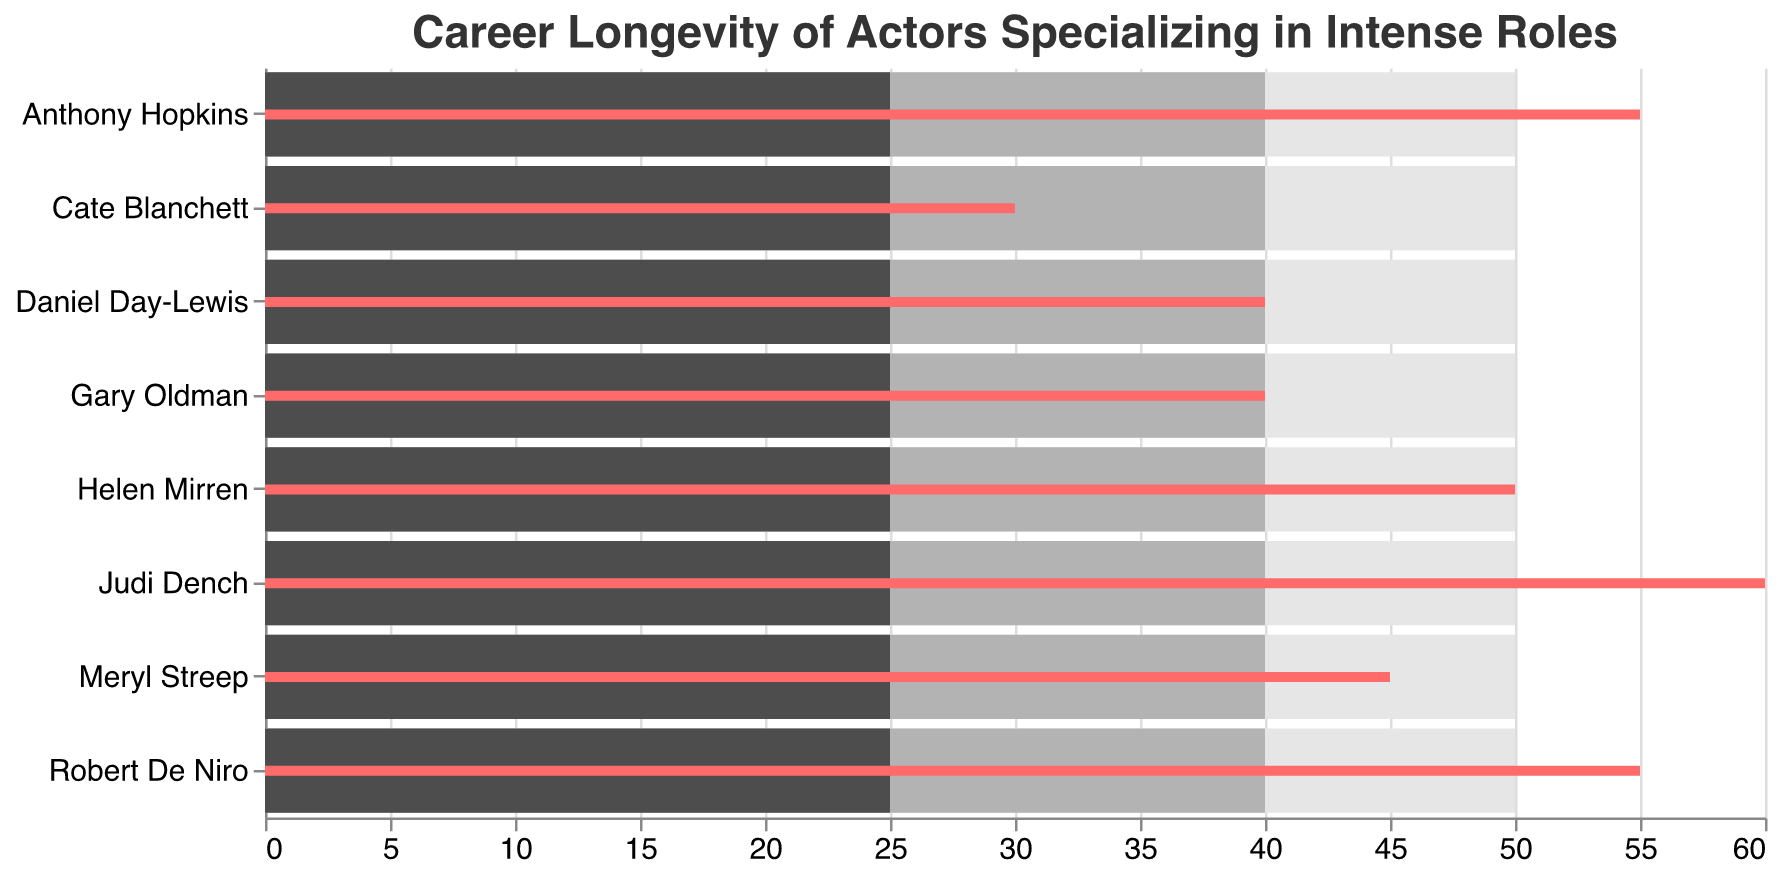What is the title of the figure? The title of the figure is displayed at the top center, setting the context for interpreting the chart. Here, the title reads "Career Longevity of Actors Specializing in Intense Roles".
Answer: "Career Longevity of Actors Specializing in Intense Roles" Which actor has been active the longest in their career? The chart has a bullet bar indicating the "Years Active" for each actor. The longest bar corresponds to Judi Dench with 60 years.
Answer: Judi Dench How many actors have been active for at least 50 years? By counting the actors with "Years Active" bars extending to at least 50 years, we see that four actors (Judi Dench, Anthony Hopkins, Helen Mirren, Robert De Niro) meet this criterion.
Answer: 4 What is the difference in "Years Active" between Meryl Streep and Cate Blanchett? Meryl Streep's bar shows 45 years, and Cate Blanchett's shows 30. Subtract the number of years (45 - 30) to find the difference.
Answer: 15 Which two actors have the same "Years Active"? By observing the bars representing "Years Active", we see that Daniel Day-Lewis and Gary Oldman both have 40 years active.
Answer: Daniel Day-Lewis and Gary Oldman What is the average career length for the actors? The "Average Career Length" is shown as a bar of consistent length across all actors, labeled as 25 years in the chart.
Answer: 25 years Are there any actors who fall short of the "Top Performer" benchmark? The "Top Performer" benchmark is shown at 40 years. Cate Blanchett, with 30 years active, falls short of this benchmark.
Answer: Cate Blanchett How many actors have surpassed the "Outstanding Performer" benchmark? The "Outstanding Performer" benchmark is set at 50 years. By reviewing the bars, we see that two actors exceed this mark: Judi Dench with 60 years and Anthony Hopkins with 55 years.
Answer: 2 What's the difference between the highest "Years Active" and the "Average Career Length"? Judi Dench has the highest "Years Active" with 60 years. The "Average Career Length" is 25 years, making the difference 60 - 25 = 35 years.
Answer: 35 years Which actors' career lengths exactly match the "Top Performer" benchmark? The "Top Performer" benchmark is set at 40 years. Both Daniel Day-Lewis and Gary Oldman have exactly 40 years of acting careers, matching this benchmark.
Answer: Daniel Day-Lewis and Gary Oldman 